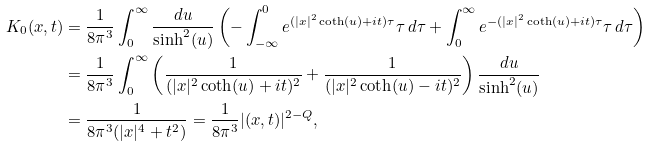<formula> <loc_0><loc_0><loc_500><loc_500>K _ { 0 } ( x , t ) & = \frac { 1 } { 8 \pi ^ { 3 } } \int _ { 0 } ^ { \infty } \frac { d u } { \sinh ^ { 2 } ( u ) } \left ( - \int _ { - \infty } ^ { 0 } e ^ { ( | x | ^ { 2 } \coth ( u ) + i t ) \tau } \tau \, d \tau + \int _ { 0 } ^ { \infty } e ^ { - ( | x | ^ { 2 } \coth ( u ) + i t ) \tau } \tau \, d \tau \right ) \\ & = \frac { 1 } { 8 \pi ^ { 3 } } \int _ { 0 } ^ { \infty } \left ( \frac { 1 } { ( | x | ^ { 2 } \coth ( u ) + i t ) ^ { 2 } } + \frac { 1 } { ( | x | ^ { 2 } \coth ( u ) - i t ) ^ { 2 } } \right ) \frac { d u } { \sinh ^ { 2 } ( u ) } \\ & = \frac { 1 } { 8 \pi ^ { 3 } ( | x | ^ { 4 } + t ^ { 2 } ) } = \frac { 1 } { 8 \pi ^ { 3 } } | ( x , t ) | ^ { 2 - Q } ,</formula> 